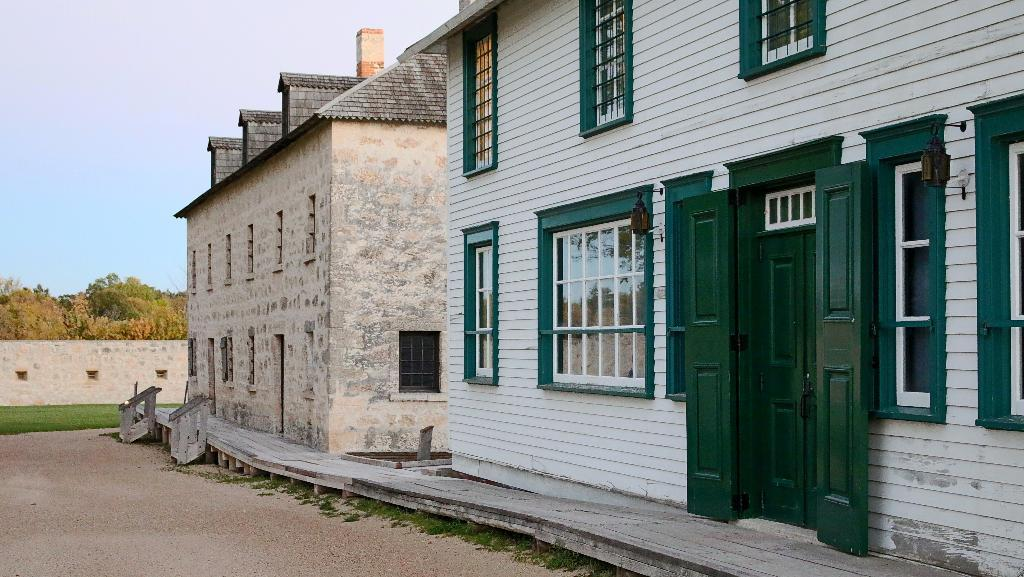What type of structures can be seen in the image? There are buildings in the image. What architectural features are visible on the buildings? There are windows and a door visible on the buildings. What type of vegetation is present in the image? There is grass and trees visible in the image. What part of the natural environment is visible in the image? The sky is visible in the image. What type of lace can be seen on the windows in the image? There is no lace visible on the windows in the image; only the windows themselves are present. 